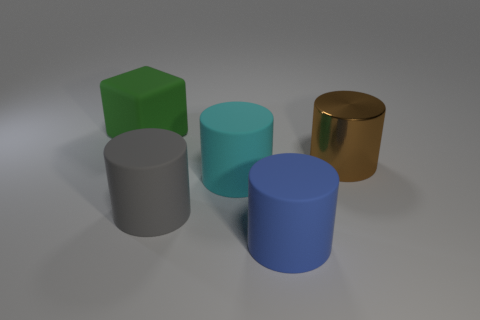There is a big thing that is to the right of the big cyan object and behind the cyan cylinder; what material is it made of?
Your response must be concise. Metal. There is a object that is on the right side of the blue matte cylinder; are there any brown metallic things on the left side of it?
Make the answer very short. No. How many big rubber cylinders are the same color as the shiny cylinder?
Your response must be concise. 0. Does the big gray thing have the same material as the big blue cylinder?
Provide a succinct answer. Yes. There is a big green object; are there any big blue matte things right of it?
Keep it short and to the point. Yes. What material is the object that is behind the big thing that is to the right of the blue rubber object made of?
Provide a short and direct response. Rubber. There is a brown object that is the same shape as the large gray matte object; what size is it?
Keep it short and to the point. Large. What color is the large matte object that is right of the large gray matte cylinder and behind the big gray thing?
Ensure brevity in your answer.  Cyan. Are there any other things that have the same shape as the large green object?
Provide a succinct answer. No. Is the gray thing made of the same material as the thing that is behind the shiny cylinder?
Keep it short and to the point. Yes. 